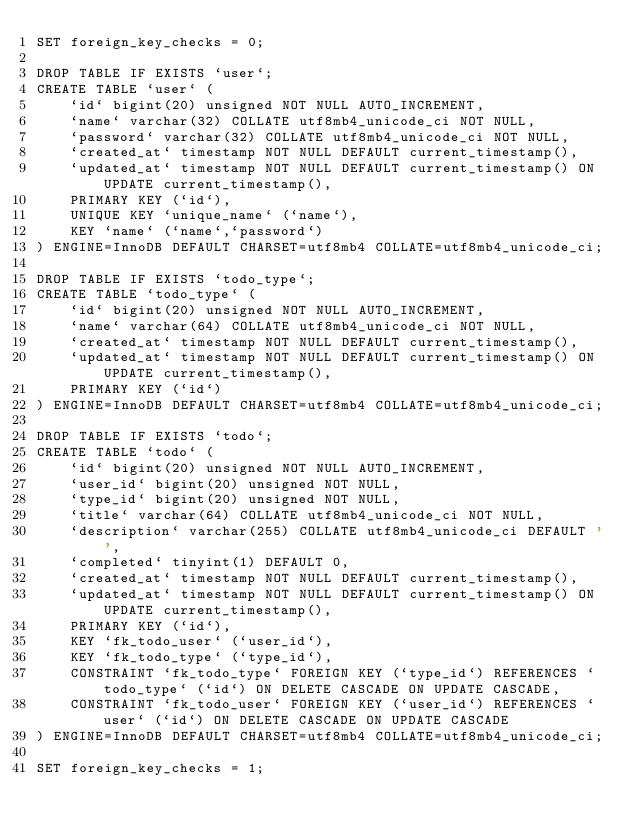Convert code to text. <code><loc_0><loc_0><loc_500><loc_500><_SQL_>SET foreign_key_checks = 0;

DROP TABLE IF EXISTS `user`;
CREATE TABLE `user` (
    `id` bigint(20) unsigned NOT NULL AUTO_INCREMENT,
    `name` varchar(32) COLLATE utf8mb4_unicode_ci NOT NULL,
    `password` varchar(32) COLLATE utf8mb4_unicode_ci NOT NULL,
    `created_at` timestamp NOT NULL DEFAULT current_timestamp(),
    `updated_at` timestamp NOT NULL DEFAULT current_timestamp() ON UPDATE current_timestamp(),
    PRIMARY KEY (`id`),
    UNIQUE KEY `unique_name` (`name`),
    KEY `name` (`name`,`password`)
) ENGINE=InnoDB DEFAULT CHARSET=utf8mb4 COLLATE=utf8mb4_unicode_ci;

DROP TABLE IF EXISTS `todo_type`;
CREATE TABLE `todo_type` (
    `id` bigint(20) unsigned NOT NULL AUTO_INCREMENT,
    `name` varchar(64) COLLATE utf8mb4_unicode_ci NOT NULL,
    `created_at` timestamp NOT NULL DEFAULT current_timestamp(),
    `updated_at` timestamp NOT NULL DEFAULT current_timestamp() ON UPDATE current_timestamp(),
    PRIMARY KEY (`id`)
) ENGINE=InnoDB DEFAULT CHARSET=utf8mb4 COLLATE=utf8mb4_unicode_ci;

DROP TABLE IF EXISTS `todo`;
CREATE TABLE `todo` (
    `id` bigint(20) unsigned NOT NULL AUTO_INCREMENT,
    `user_id` bigint(20) unsigned NOT NULL,
    `type_id` bigint(20) unsigned NOT NULL,
    `title` varchar(64) COLLATE utf8mb4_unicode_ci NOT NULL,
    `description` varchar(255) COLLATE utf8mb4_unicode_ci DEFAULT '',
    `completed` tinyint(1) DEFAULT 0,
    `created_at` timestamp NOT NULL DEFAULT current_timestamp(),
    `updated_at` timestamp NOT NULL DEFAULT current_timestamp() ON UPDATE current_timestamp(),
    PRIMARY KEY (`id`),
    KEY `fk_todo_user` (`user_id`),
    KEY `fk_todo_type` (`type_id`),
    CONSTRAINT `fk_todo_type` FOREIGN KEY (`type_id`) REFERENCES `todo_type` (`id`) ON DELETE CASCADE ON UPDATE CASCADE,
    CONSTRAINT `fk_todo_user` FOREIGN KEY (`user_id`) REFERENCES `user` (`id`) ON DELETE CASCADE ON UPDATE CASCADE
) ENGINE=InnoDB DEFAULT CHARSET=utf8mb4 COLLATE=utf8mb4_unicode_ci;

SET foreign_key_checks = 1;
</code> 